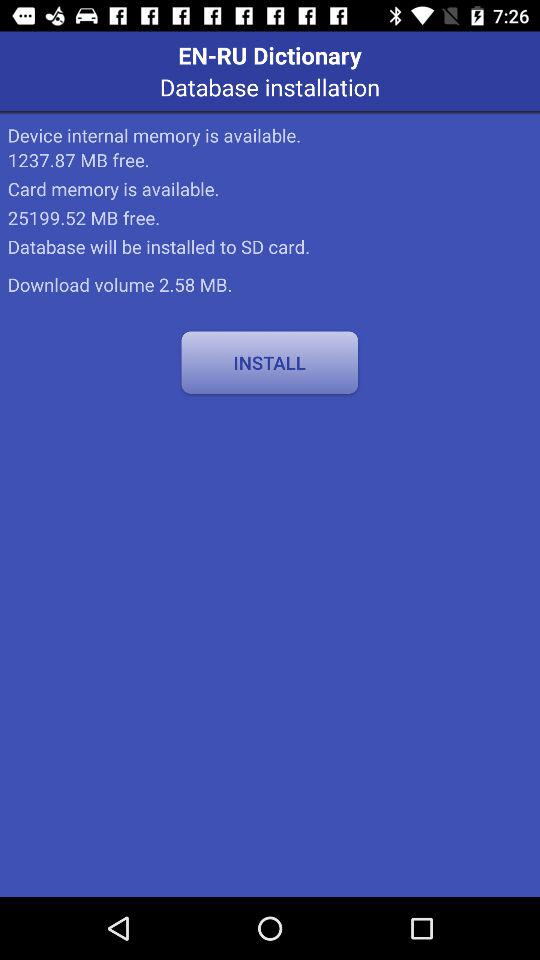What is the download volume? The download volume is 2.58 MB. 